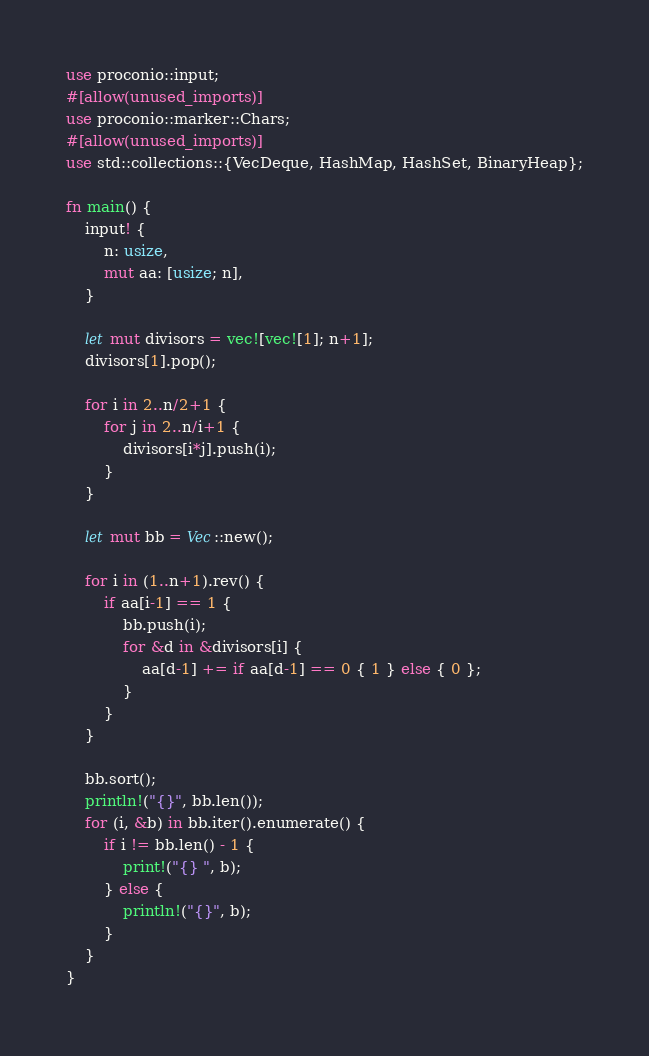<code> <loc_0><loc_0><loc_500><loc_500><_Rust_>use proconio::input;
#[allow(unused_imports)]
use proconio::marker::Chars;
#[allow(unused_imports)]
use std::collections::{VecDeque, HashMap, HashSet, BinaryHeap};

fn main() {
    input! {
        n: usize,
        mut aa: [usize; n],
    }

    let mut divisors = vec![vec![1]; n+1];
    divisors[1].pop();

    for i in 2..n/2+1 {
        for j in 2..n/i+1 {
            divisors[i*j].push(i);
        }
    }

    let mut bb = Vec::new();

    for i in (1..n+1).rev() {
        if aa[i-1] == 1 {
            bb.push(i);
            for &d in &divisors[i] {
                aa[d-1] += if aa[d-1] == 0 { 1 } else { 0 };
            }
        }
    }

    bb.sort();
    println!("{}", bb.len());
    for (i, &b) in bb.iter().enumerate() {
        if i != bb.len() - 1 {
            print!("{} ", b);
        } else {
            println!("{}", b);
        }
    }
}
</code> 